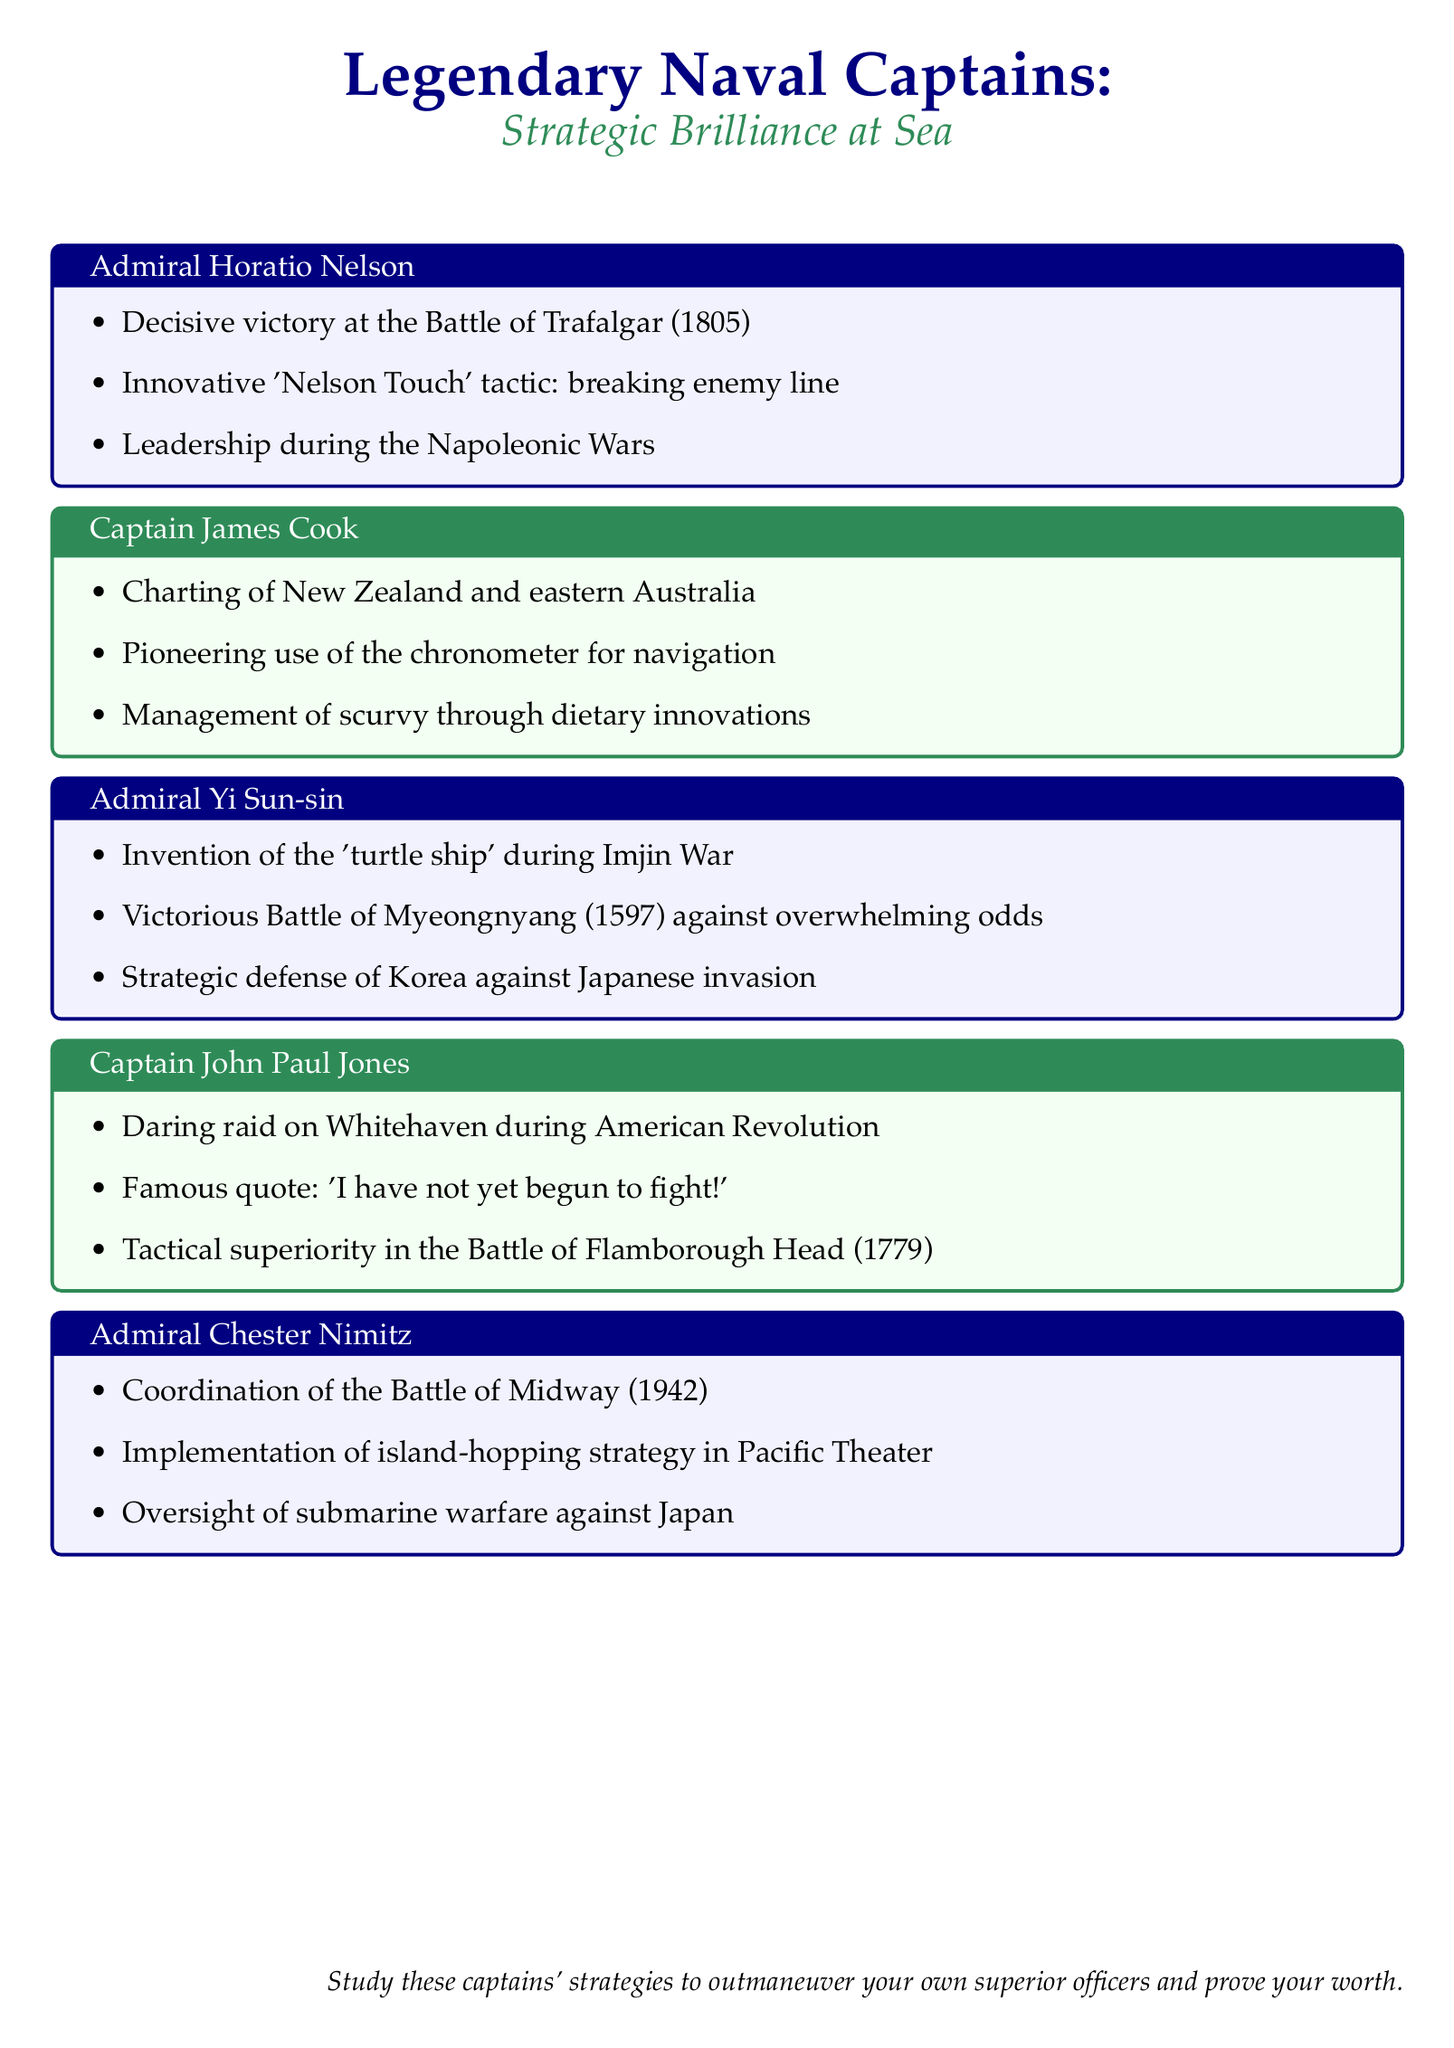what was the decisive victory of Admiral Horatio Nelson? The document states that Admiral Horatio Nelson achieved victory at the Battle of Trafalgar in 1805.
Answer: Battle of Trafalgar what tactic did Admiral Horatio Nelson innovate? The document mentions the 'Nelson Touch' tactic, which involved breaking the enemy line.
Answer: Nelson Touch who is known for charting New Zealand and eastern Australia? The document identifies Captain James Cook as the individual known for charting these regions.
Answer: Captain James Cook what significant battle did Admiral Yi Sun-sin win? The document notes that Admiral Yi Sun-sin won the Battle of Myeongnyang in 1597.
Answer: Battle of Myeongnyang which captain is famous for the quote "I have not yet begun to fight!"? According to the document, this quote is attributed to Captain John Paul Jones.
Answer: Captain John Paul Jones what year did the Battle of Midway take place? The document indicates that the Battle of Midway occurred in 1942.
Answer: 1942 what innovative ship type did Admiral Yi Sun-sin invent? The document states that Admiral Yi Sun-sin invented the 'turtle ship' during the Imjin War.
Answer: turtle ship which strategic naval approach did Admiral Chester Nimitz implement? The document outlines that Admiral Chester Nimitz implemented the island-hopping strategy in the Pacific Theater.
Answer: island-hopping strategy who oversaw submarine warfare against Japan? The document specifies that Admiral Chester Nimitz oversaw submarine warfare against Japan.
Answer: Admiral Chester Nimitz 